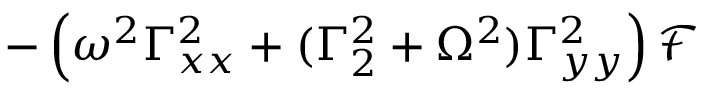<formula> <loc_0><loc_0><loc_500><loc_500>- \left ( \omega ^ { 2 } \Gamma _ { x x } ^ { 2 } + ( \Gamma _ { 2 } ^ { 2 } + \Omega ^ { 2 } ) \Gamma _ { y y } ^ { 2 } \right ) \mathcal { F }</formula> 